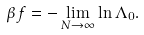<formula> <loc_0><loc_0><loc_500><loc_500>\beta f = - \lim _ { N \rightarrow \infty } \ln \Lambda _ { 0 } .</formula> 